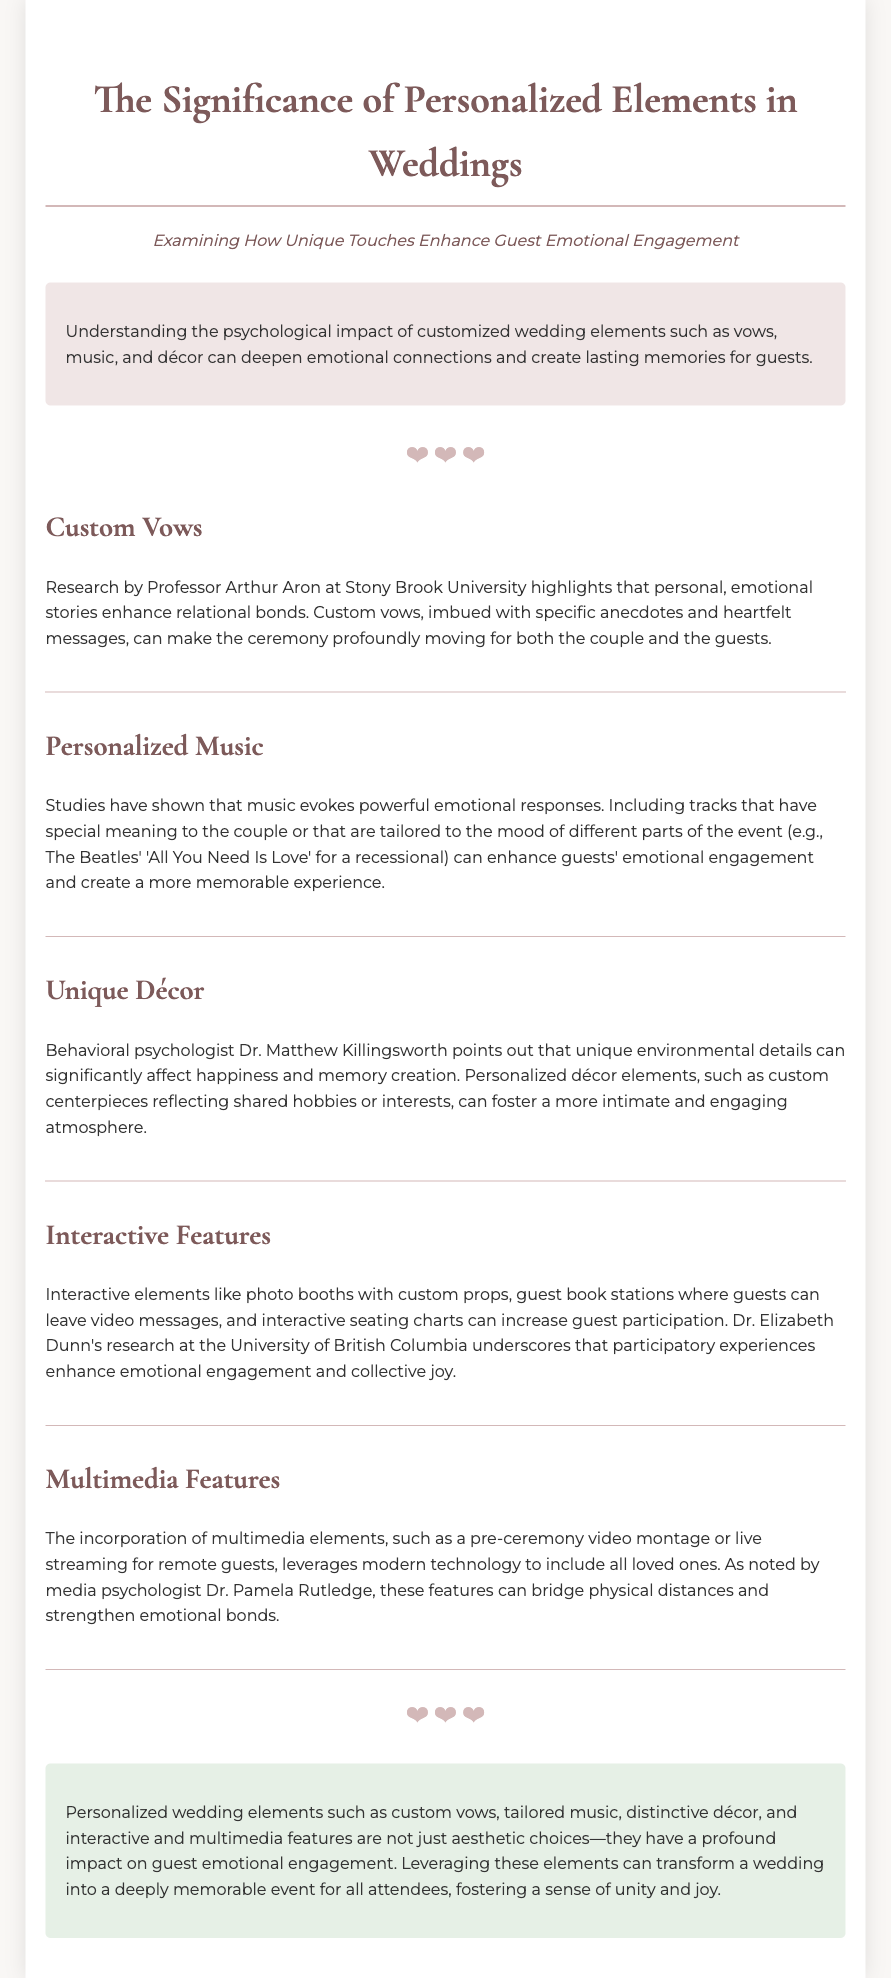What is the title of the document? The title is displayed prominently at the top of the document, which is “The Significance of Personalized Elements in Weddings.”
Answer: The Significance of Personalized Elements in Weddings What are custom vows? Custom vows are defined in the document as personal, emotional stories that enhance relational bonds during the wedding ceremony.
Answer: Personal, emotional stories Who conducted research on the impact of custom vows? The document mentions Professor Arthur Aron from Stony Brook University as the researcher in this area.
Answer: Professor Arthur Aron What song title is referenced for the recessional? The document provides "All You Need Is Love" as an example of music with special meaning for the couple.
Answer: All You Need Is Love What type of interactive features are included in weddings? The document lists photo booths with custom props and guest book stations for video messages as interactive features.
Answer: Photo booths with custom props How do unique décor elements affect guests? The document states that unique environmental details can significantly affect happiness and memory creation, according to Dr. Matthew Killingsworth.
Answer: Happiness and memory creation Which researcher's work highlights the impact of participatory experiences? Dr. Elizabeth Dunn's research at the University of British Columbia is noted for emphasizing this effect.
Answer: Dr. Elizabeth Dunn What are multimedia features mentioned in the document? The document cites pre-ceremony video montages and live streaming for remote guests as examples of multimedia features.
Answer: Pre-ceremony video montages and live streaming What emotional response do interactive elements aim to enhance? The participation through interactive elements is intended to enhance emotional engagement and collective joy among guests.
Answer: Emotional engagement and collective joy 